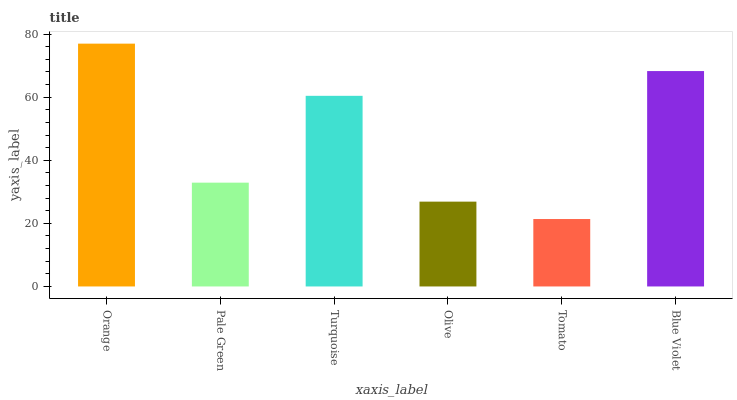Is Tomato the minimum?
Answer yes or no. Yes. Is Orange the maximum?
Answer yes or no. Yes. Is Pale Green the minimum?
Answer yes or no. No. Is Pale Green the maximum?
Answer yes or no. No. Is Orange greater than Pale Green?
Answer yes or no. Yes. Is Pale Green less than Orange?
Answer yes or no. Yes. Is Pale Green greater than Orange?
Answer yes or no. No. Is Orange less than Pale Green?
Answer yes or no. No. Is Turquoise the high median?
Answer yes or no. Yes. Is Pale Green the low median?
Answer yes or no. Yes. Is Orange the high median?
Answer yes or no. No. Is Tomato the low median?
Answer yes or no. No. 